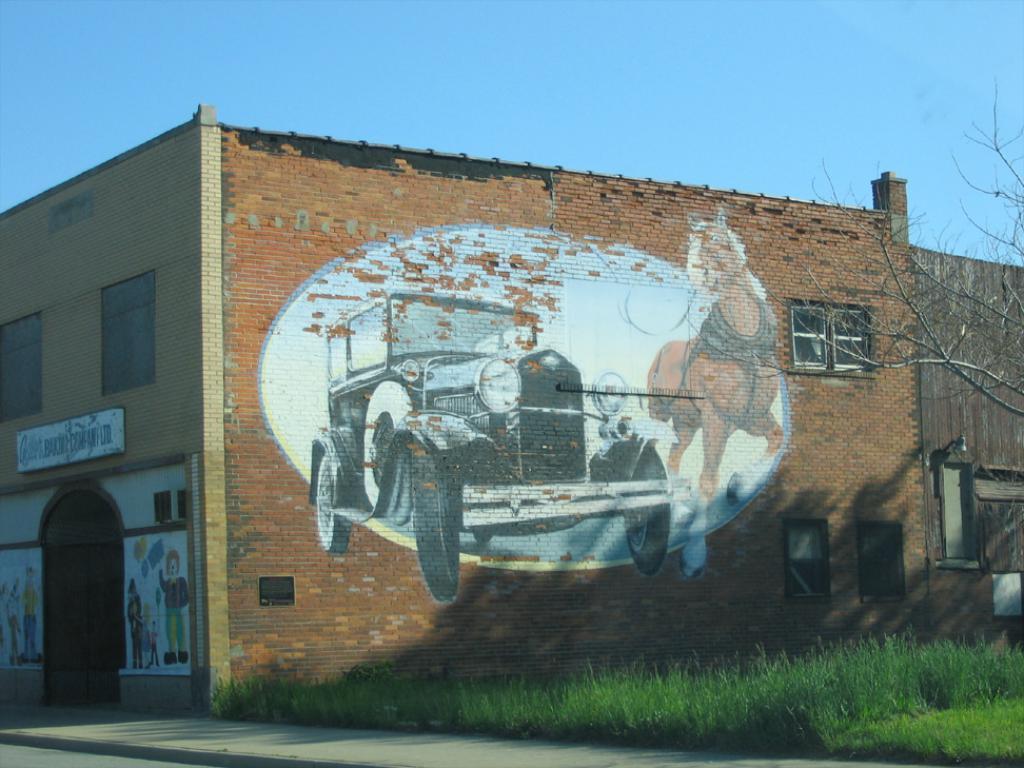Please provide a concise description of this image. There is a building which has a picture on it and there is a greenery ground beside it and the sky is blue in color. 